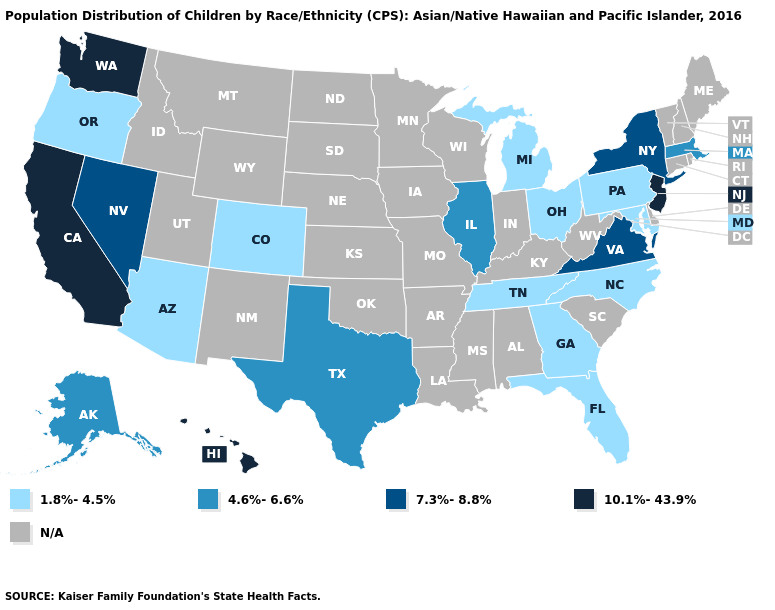Name the states that have a value in the range 10.1%-43.9%?
Quick response, please. California, Hawaii, New Jersey, Washington. Does the map have missing data?
Short answer required. Yes. Among the states that border Michigan , which have the highest value?
Give a very brief answer. Ohio. What is the value of Alaska?
Be succinct. 4.6%-6.6%. Does California have the highest value in the USA?
Short answer required. Yes. How many symbols are there in the legend?
Keep it brief. 5. What is the value of California?
Be succinct. 10.1%-43.9%. Name the states that have a value in the range 10.1%-43.9%?
Write a very short answer. California, Hawaii, New Jersey, Washington. What is the lowest value in the USA?
Concise answer only. 1.8%-4.5%. Among the states that border New York , which have the highest value?
Answer briefly. New Jersey. Name the states that have a value in the range 1.8%-4.5%?
Give a very brief answer. Arizona, Colorado, Florida, Georgia, Maryland, Michigan, North Carolina, Ohio, Oregon, Pennsylvania, Tennessee. Among the states that border Pennsylvania , which have the highest value?
Be succinct. New Jersey. What is the lowest value in the South?
Write a very short answer. 1.8%-4.5%. Is the legend a continuous bar?
Concise answer only. No. 